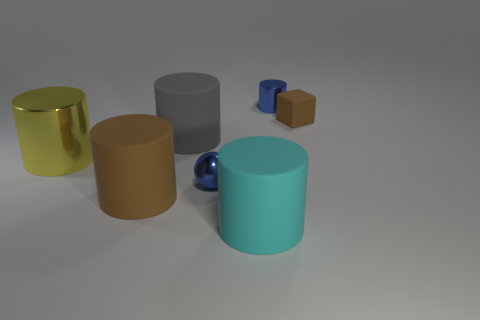Subtract all yellow cylinders. How many cylinders are left? 4 Subtract all blue metal cylinders. How many cylinders are left? 4 Add 3 small objects. How many objects exist? 10 Subtract all purple cylinders. Subtract all cyan spheres. How many cylinders are left? 5 Subtract all cylinders. How many objects are left? 2 Add 1 brown rubber cylinders. How many brown rubber cylinders exist? 2 Subtract 0 green balls. How many objects are left? 7 Subtract all tiny green matte spheres. Subtract all small blue metallic cylinders. How many objects are left? 6 Add 2 brown cubes. How many brown cubes are left? 3 